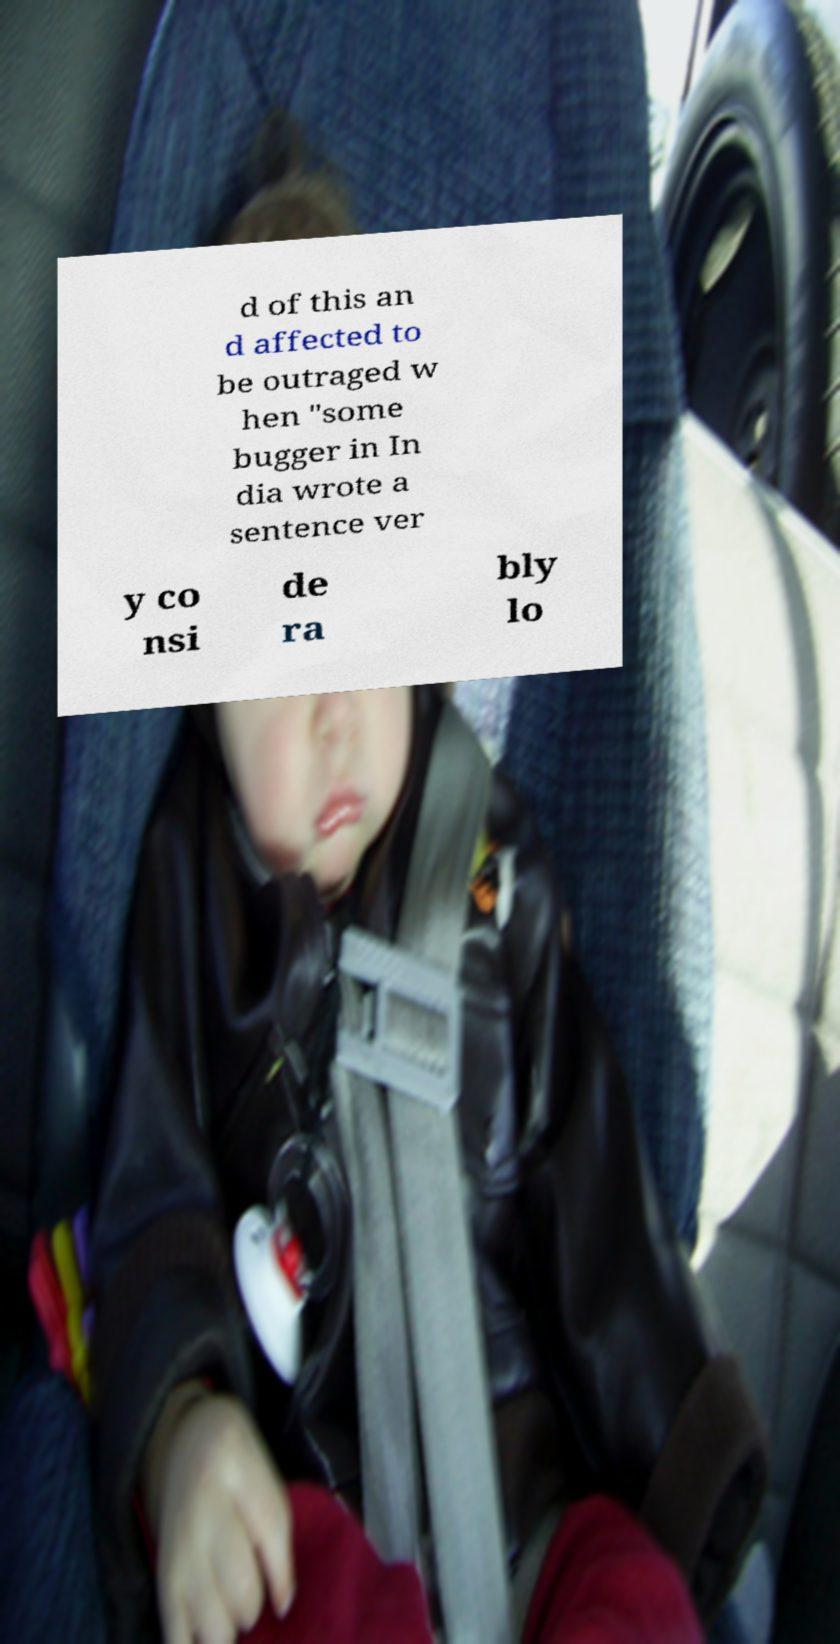I need the written content from this picture converted into text. Can you do that? d of this an d affected to be outraged w hen "some bugger in In dia wrote a sentence ver y co nsi de ra bly lo 